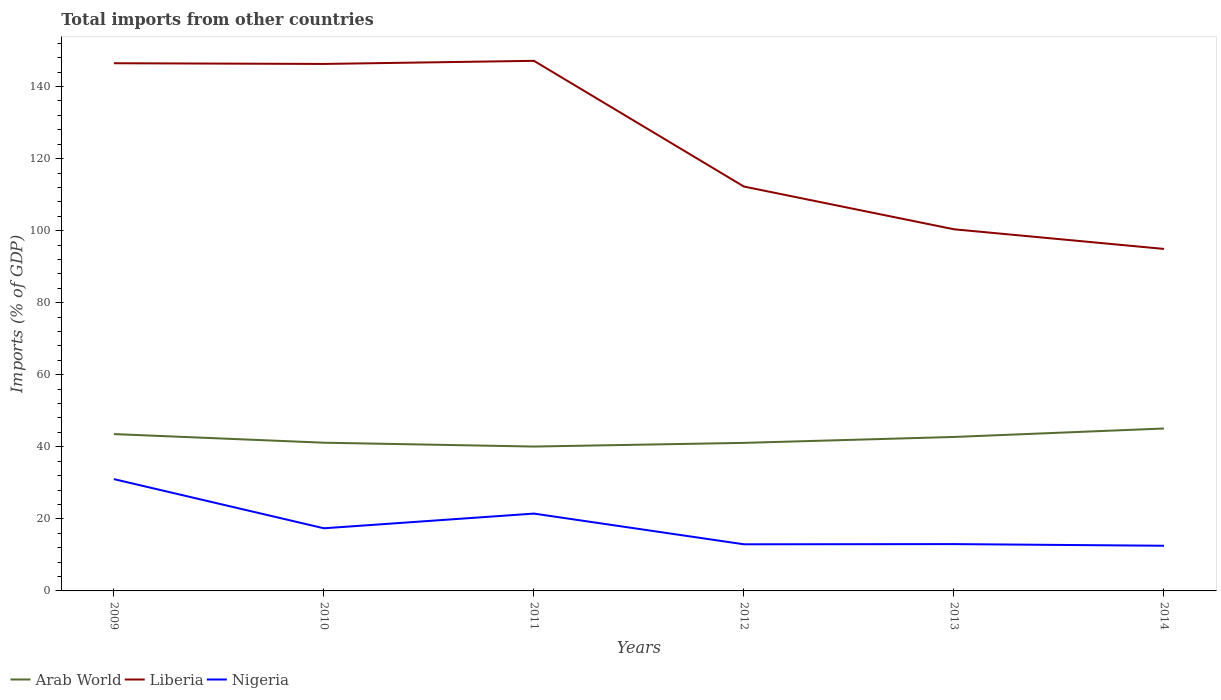Is the number of lines equal to the number of legend labels?
Provide a short and direct response. Yes. Across all years, what is the maximum total imports in Liberia?
Your answer should be very brief. 94.93. What is the total total imports in Nigeria in the graph?
Keep it short and to the point. 8.93. What is the difference between the highest and the second highest total imports in Nigeria?
Provide a succinct answer. 18.5. What is the difference between the highest and the lowest total imports in Liberia?
Your answer should be very brief. 3. Is the total imports in Liberia strictly greater than the total imports in Nigeria over the years?
Provide a short and direct response. No. How many years are there in the graph?
Keep it short and to the point. 6. Are the values on the major ticks of Y-axis written in scientific E-notation?
Your answer should be compact. No. Does the graph contain grids?
Your answer should be very brief. No. Where does the legend appear in the graph?
Provide a succinct answer. Bottom left. What is the title of the graph?
Give a very brief answer. Total imports from other countries. What is the label or title of the X-axis?
Offer a very short reply. Years. What is the label or title of the Y-axis?
Offer a very short reply. Imports (% of GDP). What is the Imports (% of GDP) in Arab World in 2009?
Give a very brief answer. 43.54. What is the Imports (% of GDP) in Liberia in 2009?
Keep it short and to the point. 146.47. What is the Imports (% of GDP) in Nigeria in 2009?
Ensure brevity in your answer.  31.03. What is the Imports (% of GDP) of Arab World in 2010?
Your answer should be very brief. 41.14. What is the Imports (% of GDP) in Liberia in 2010?
Give a very brief answer. 146.28. What is the Imports (% of GDP) in Nigeria in 2010?
Your answer should be compact. 17.39. What is the Imports (% of GDP) of Arab World in 2011?
Offer a terse response. 40.07. What is the Imports (% of GDP) of Liberia in 2011?
Your answer should be compact. 147.15. What is the Imports (% of GDP) of Nigeria in 2011?
Make the answer very short. 21.46. What is the Imports (% of GDP) in Arab World in 2012?
Keep it short and to the point. 41.1. What is the Imports (% of GDP) in Liberia in 2012?
Make the answer very short. 112.24. What is the Imports (% of GDP) of Nigeria in 2012?
Your response must be concise. 12.94. What is the Imports (% of GDP) in Arab World in 2013?
Your answer should be very brief. 42.74. What is the Imports (% of GDP) of Liberia in 2013?
Keep it short and to the point. 100.39. What is the Imports (% of GDP) in Nigeria in 2013?
Your response must be concise. 13. What is the Imports (% of GDP) of Arab World in 2014?
Give a very brief answer. 45.08. What is the Imports (% of GDP) of Liberia in 2014?
Give a very brief answer. 94.93. What is the Imports (% of GDP) of Nigeria in 2014?
Your response must be concise. 12.54. Across all years, what is the maximum Imports (% of GDP) of Arab World?
Offer a terse response. 45.08. Across all years, what is the maximum Imports (% of GDP) in Liberia?
Keep it short and to the point. 147.15. Across all years, what is the maximum Imports (% of GDP) of Nigeria?
Your answer should be very brief. 31.03. Across all years, what is the minimum Imports (% of GDP) in Arab World?
Your response must be concise. 40.07. Across all years, what is the minimum Imports (% of GDP) of Liberia?
Keep it short and to the point. 94.93. Across all years, what is the minimum Imports (% of GDP) in Nigeria?
Ensure brevity in your answer.  12.54. What is the total Imports (% of GDP) of Arab World in the graph?
Make the answer very short. 253.67. What is the total Imports (% of GDP) in Liberia in the graph?
Keep it short and to the point. 747.47. What is the total Imports (% of GDP) in Nigeria in the graph?
Provide a short and direct response. 108.36. What is the difference between the Imports (% of GDP) in Arab World in 2009 and that in 2010?
Your response must be concise. 2.39. What is the difference between the Imports (% of GDP) in Liberia in 2009 and that in 2010?
Make the answer very short. 0.19. What is the difference between the Imports (% of GDP) in Nigeria in 2009 and that in 2010?
Offer a very short reply. 13.65. What is the difference between the Imports (% of GDP) of Arab World in 2009 and that in 2011?
Make the answer very short. 3.46. What is the difference between the Imports (% of GDP) in Liberia in 2009 and that in 2011?
Ensure brevity in your answer.  -0.67. What is the difference between the Imports (% of GDP) of Nigeria in 2009 and that in 2011?
Offer a very short reply. 9.57. What is the difference between the Imports (% of GDP) in Arab World in 2009 and that in 2012?
Keep it short and to the point. 2.44. What is the difference between the Imports (% of GDP) of Liberia in 2009 and that in 2012?
Offer a terse response. 34.23. What is the difference between the Imports (% of GDP) in Nigeria in 2009 and that in 2012?
Provide a succinct answer. 18.09. What is the difference between the Imports (% of GDP) in Arab World in 2009 and that in 2013?
Ensure brevity in your answer.  0.8. What is the difference between the Imports (% of GDP) in Liberia in 2009 and that in 2013?
Give a very brief answer. 46.09. What is the difference between the Imports (% of GDP) of Nigeria in 2009 and that in 2013?
Your response must be concise. 18.04. What is the difference between the Imports (% of GDP) in Arab World in 2009 and that in 2014?
Keep it short and to the point. -1.55. What is the difference between the Imports (% of GDP) of Liberia in 2009 and that in 2014?
Offer a very short reply. 51.54. What is the difference between the Imports (% of GDP) in Nigeria in 2009 and that in 2014?
Keep it short and to the point. 18.5. What is the difference between the Imports (% of GDP) in Arab World in 2010 and that in 2011?
Your answer should be very brief. 1.07. What is the difference between the Imports (% of GDP) of Liberia in 2010 and that in 2011?
Your answer should be very brief. -0.86. What is the difference between the Imports (% of GDP) in Nigeria in 2010 and that in 2011?
Offer a very short reply. -4.08. What is the difference between the Imports (% of GDP) of Arab World in 2010 and that in 2012?
Provide a short and direct response. 0.05. What is the difference between the Imports (% of GDP) in Liberia in 2010 and that in 2012?
Your response must be concise. 34.04. What is the difference between the Imports (% of GDP) in Nigeria in 2010 and that in 2012?
Your answer should be very brief. 4.45. What is the difference between the Imports (% of GDP) of Arab World in 2010 and that in 2013?
Give a very brief answer. -1.59. What is the difference between the Imports (% of GDP) in Liberia in 2010 and that in 2013?
Ensure brevity in your answer.  45.9. What is the difference between the Imports (% of GDP) in Nigeria in 2010 and that in 2013?
Provide a short and direct response. 4.39. What is the difference between the Imports (% of GDP) in Arab World in 2010 and that in 2014?
Provide a short and direct response. -3.94. What is the difference between the Imports (% of GDP) of Liberia in 2010 and that in 2014?
Your response must be concise. 51.35. What is the difference between the Imports (% of GDP) in Nigeria in 2010 and that in 2014?
Provide a succinct answer. 4.85. What is the difference between the Imports (% of GDP) in Arab World in 2011 and that in 2012?
Your response must be concise. -1.02. What is the difference between the Imports (% of GDP) of Liberia in 2011 and that in 2012?
Your answer should be compact. 34.9. What is the difference between the Imports (% of GDP) of Nigeria in 2011 and that in 2012?
Your answer should be very brief. 8.52. What is the difference between the Imports (% of GDP) in Arab World in 2011 and that in 2013?
Offer a very short reply. -2.66. What is the difference between the Imports (% of GDP) in Liberia in 2011 and that in 2013?
Your response must be concise. 46.76. What is the difference between the Imports (% of GDP) of Nigeria in 2011 and that in 2013?
Ensure brevity in your answer.  8.47. What is the difference between the Imports (% of GDP) of Arab World in 2011 and that in 2014?
Keep it short and to the point. -5.01. What is the difference between the Imports (% of GDP) of Liberia in 2011 and that in 2014?
Ensure brevity in your answer.  52.21. What is the difference between the Imports (% of GDP) in Nigeria in 2011 and that in 2014?
Your answer should be very brief. 8.93. What is the difference between the Imports (% of GDP) in Arab World in 2012 and that in 2013?
Offer a very short reply. -1.64. What is the difference between the Imports (% of GDP) in Liberia in 2012 and that in 2013?
Ensure brevity in your answer.  11.86. What is the difference between the Imports (% of GDP) of Nigeria in 2012 and that in 2013?
Ensure brevity in your answer.  -0.06. What is the difference between the Imports (% of GDP) of Arab World in 2012 and that in 2014?
Offer a very short reply. -3.99. What is the difference between the Imports (% of GDP) in Liberia in 2012 and that in 2014?
Your answer should be very brief. 17.31. What is the difference between the Imports (% of GDP) in Nigeria in 2012 and that in 2014?
Keep it short and to the point. 0.4. What is the difference between the Imports (% of GDP) in Arab World in 2013 and that in 2014?
Your response must be concise. -2.35. What is the difference between the Imports (% of GDP) of Liberia in 2013 and that in 2014?
Give a very brief answer. 5.45. What is the difference between the Imports (% of GDP) of Nigeria in 2013 and that in 2014?
Provide a short and direct response. 0.46. What is the difference between the Imports (% of GDP) in Arab World in 2009 and the Imports (% of GDP) in Liberia in 2010?
Give a very brief answer. -102.75. What is the difference between the Imports (% of GDP) of Arab World in 2009 and the Imports (% of GDP) of Nigeria in 2010?
Your answer should be very brief. 26.15. What is the difference between the Imports (% of GDP) in Liberia in 2009 and the Imports (% of GDP) in Nigeria in 2010?
Your answer should be compact. 129.09. What is the difference between the Imports (% of GDP) of Arab World in 2009 and the Imports (% of GDP) of Liberia in 2011?
Your response must be concise. -103.61. What is the difference between the Imports (% of GDP) in Arab World in 2009 and the Imports (% of GDP) in Nigeria in 2011?
Offer a terse response. 22.07. What is the difference between the Imports (% of GDP) in Liberia in 2009 and the Imports (% of GDP) in Nigeria in 2011?
Ensure brevity in your answer.  125.01. What is the difference between the Imports (% of GDP) of Arab World in 2009 and the Imports (% of GDP) of Liberia in 2012?
Your answer should be very brief. -68.71. What is the difference between the Imports (% of GDP) of Arab World in 2009 and the Imports (% of GDP) of Nigeria in 2012?
Give a very brief answer. 30.59. What is the difference between the Imports (% of GDP) of Liberia in 2009 and the Imports (% of GDP) of Nigeria in 2012?
Keep it short and to the point. 133.53. What is the difference between the Imports (% of GDP) of Arab World in 2009 and the Imports (% of GDP) of Liberia in 2013?
Provide a succinct answer. -56.85. What is the difference between the Imports (% of GDP) in Arab World in 2009 and the Imports (% of GDP) in Nigeria in 2013?
Your answer should be compact. 30.54. What is the difference between the Imports (% of GDP) of Liberia in 2009 and the Imports (% of GDP) of Nigeria in 2013?
Keep it short and to the point. 133.48. What is the difference between the Imports (% of GDP) of Arab World in 2009 and the Imports (% of GDP) of Liberia in 2014?
Give a very brief answer. -51.4. What is the difference between the Imports (% of GDP) of Arab World in 2009 and the Imports (% of GDP) of Nigeria in 2014?
Offer a terse response. 31. What is the difference between the Imports (% of GDP) in Liberia in 2009 and the Imports (% of GDP) in Nigeria in 2014?
Keep it short and to the point. 133.94. What is the difference between the Imports (% of GDP) in Arab World in 2010 and the Imports (% of GDP) in Liberia in 2011?
Give a very brief answer. -106. What is the difference between the Imports (% of GDP) of Arab World in 2010 and the Imports (% of GDP) of Nigeria in 2011?
Your answer should be compact. 19.68. What is the difference between the Imports (% of GDP) of Liberia in 2010 and the Imports (% of GDP) of Nigeria in 2011?
Offer a terse response. 124.82. What is the difference between the Imports (% of GDP) of Arab World in 2010 and the Imports (% of GDP) of Liberia in 2012?
Your response must be concise. -71.1. What is the difference between the Imports (% of GDP) in Arab World in 2010 and the Imports (% of GDP) in Nigeria in 2012?
Offer a very short reply. 28.2. What is the difference between the Imports (% of GDP) of Liberia in 2010 and the Imports (% of GDP) of Nigeria in 2012?
Your answer should be compact. 133.34. What is the difference between the Imports (% of GDP) of Arab World in 2010 and the Imports (% of GDP) of Liberia in 2013?
Offer a very short reply. -59.24. What is the difference between the Imports (% of GDP) in Arab World in 2010 and the Imports (% of GDP) in Nigeria in 2013?
Your answer should be compact. 28.14. What is the difference between the Imports (% of GDP) of Liberia in 2010 and the Imports (% of GDP) of Nigeria in 2013?
Give a very brief answer. 133.28. What is the difference between the Imports (% of GDP) in Arab World in 2010 and the Imports (% of GDP) in Liberia in 2014?
Offer a terse response. -53.79. What is the difference between the Imports (% of GDP) of Arab World in 2010 and the Imports (% of GDP) of Nigeria in 2014?
Offer a very short reply. 28.61. What is the difference between the Imports (% of GDP) of Liberia in 2010 and the Imports (% of GDP) of Nigeria in 2014?
Give a very brief answer. 133.75. What is the difference between the Imports (% of GDP) in Arab World in 2011 and the Imports (% of GDP) in Liberia in 2012?
Provide a short and direct response. -72.17. What is the difference between the Imports (% of GDP) in Arab World in 2011 and the Imports (% of GDP) in Nigeria in 2012?
Your response must be concise. 27.13. What is the difference between the Imports (% of GDP) of Liberia in 2011 and the Imports (% of GDP) of Nigeria in 2012?
Provide a succinct answer. 134.21. What is the difference between the Imports (% of GDP) of Arab World in 2011 and the Imports (% of GDP) of Liberia in 2013?
Your answer should be compact. -60.31. What is the difference between the Imports (% of GDP) of Arab World in 2011 and the Imports (% of GDP) of Nigeria in 2013?
Make the answer very short. 27.08. What is the difference between the Imports (% of GDP) in Liberia in 2011 and the Imports (% of GDP) in Nigeria in 2013?
Keep it short and to the point. 134.15. What is the difference between the Imports (% of GDP) in Arab World in 2011 and the Imports (% of GDP) in Liberia in 2014?
Provide a short and direct response. -54.86. What is the difference between the Imports (% of GDP) in Arab World in 2011 and the Imports (% of GDP) in Nigeria in 2014?
Ensure brevity in your answer.  27.54. What is the difference between the Imports (% of GDP) of Liberia in 2011 and the Imports (% of GDP) of Nigeria in 2014?
Your answer should be compact. 134.61. What is the difference between the Imports (% of GDP) in Arab World in 2012 and the Imports (% of GDP) in Liberia in 2013?
Ensure brevity in your answer.  -59.29. What is the difference between the Imports (% of GDP) of Arab World in 2012 and the Imports (% of GDP) of Nigeria in 2013?
Make the answer very short. 28.1. What is the difference between the Imports (% of GDP) in Liberia in 2012 and the Imports (% of GDP) in Nigeria in 2013?
Your response must be concise. 99.25. What is the difference between the Imports (% of GDP) in Arab World in 2012 and the Imports (% of GDP) in Liberia in 2014?
Ensure brevity in your answer.  -53.84. What is the difference between the Imports (% of GDP) in Arab World in 2012 and the Imports (% of GDP) in Nigeria in 2014?
Your answer should be compact. 28.56. What is the difference between the Imports (% of GDP) in Liberia in 2012 and the Imports (% of GDP) in Nigeria in 2014?
Offer a terse response. 99.71. What is the difference between the Imports (% of GDP) of Arab World in 2013 and the Imports (% of GDP) of Liberia in 2014?
Provide a succinct answer. -52.2. What is the difference between the Imports (% of GDP) of Arab World in 2013 and the Imports (% of GDP) of Nigeria in 2014?
Offer a very short reply. 30.2. What is the difference between the Imports (% of GDP) of Liberia in 2013 and the Imports (% of GDP) of Nigeria in 2014?
Make the answer very short. 87.85. What is the average Imports (% of GDP) in Arab World per year?
Your answer should be compact. 42.28. What is the average Imports (% of GDP) of Liberia per year?
Provide a short and direct response. 124.58. What is the average Imports (% of GDP) in Nigeria per year?
Ensure brevity in your answer.  18.06. In the year 2009, what is the difference between the Imports (% of GDP) of Arab World and Imports (% of GDP) of Liberia?
Your answer should be compact. -102.94. In the year 2009, what is the difference between the Imports (% of GDP) in Arab World and Imports (% of GDP) in Nigeria?
Your answer should be very brief. 12.5. In the year 2009, what is the difference between the Imports (% of GDP) in Liberia and Imports (% of GDP) in Nigeria?
Your answer should be compact. 115.44. In the year 2010, what is the difference between the Imports (% of GDP) of Arab World and Imports (% of GDP) of Liberia?
Your answer should be very brief. -105.14. In the year 2010, what is the difference between the Imports (% of GDP) in Arab World and Imports (% of GDP) in Nigeria?
Your response must be concise. 23.76. In the year 2010, what is the difference between the Imports (% of GDP) in Liberia and Imports (% of GDP) in Nigeria?
Your response must be concise. 128.9. In the year 2011, what is the difference between the Imports (% of GDP) of Arab World and Imports (% of GDP) of Liberia?
Your answer should be compact. -107.07. In the year 2011, what is the difference between the Imports (% of GDP) of Arab World and Imports (% of GDP) of Nigeria?
Offer a terse response. 18.61. In the year 2011, what is the difference between the Imports (% of GDP) of Liberia and Imports (% of GDP) of Nigeria?
Your answer should be very brief. 125.68. In the year 2012, what is the difference between the Imports (% of GDP) in Arab World and Imports (% of GDP) in Liberia?
Your answer should be very brief. -71.15. In the year 2012, what is the difference between the Imports (% of GDP) of Arab World and Imports (% of GDP) of Nigeria?
Make the answer very short. 28.16. In the year 2012, what is the difference between the Imports (% of GDP) of Liberia and Imports (% of GDP) of Nigeria?
Provide a short and direct response. 99.3. In the year 2013, what is the difference between the Imports (% of GDP) in Arab World and Imports (% of GDP) in Liberia?
Keep it short and to the point. -57.65. In the year 2013, what is the difference between the Imports (% of GDP) in Arab World and Imports (% of GDP) in Nigeria?
Provide a short and direct response. 29.74. In the year 2013, what is the difference between the Imports (% of GDP) of Liberia and Imports (% of GDP) of Nigeria?
Offer a terse response. 87.39. In the year 2014, what is the difference between the Imports (% of GDP) in Arab World and Imports (% of GDP) in Liberia?
Your answer should be very brief. -49.85. In the year 2014, what is the difference between the Imports (% of GDP) in Arab World and Imports (% of GDP) in Nigeria?
Your answer should be compact. 32.55. In the year 2014, what is the difference between the Imports (% of GDP) in Liberia and Imports (% of GDP) in Nigeria?
Provide a short and direct response. 82.4. What is the ratio of the Imports (% of GDP) of Arab World in 2009 to that in 2010?
Your answer should be compact. 1.06. What is the ratio of the Imports (% of GDP) of Nigeria in 2009 to that in 2010?
Offer a very short reply. 1.78. What is the ratio of the Imports (% of GDP) in Arab World in 2009 to that in 2011?
Your answer should be very brief. 1.09. What is the ratio of the Imports (% of GDP) in Nigeria in 2009 to that in 2011?
Offer a terse response. 1.45. What is the ratio of the Imports (% of GDP) in Arab World in 2009 to that in 2012?
Your response must be concise. 1.06. What is the ratio of the Imports (% of GDP) of Liberia in 2009 to that in 2012?
Your answer should be very brief. 1.3. What is the ratio of the Imports (% of GDP) in Nigeria in 2009 to that in 2012?
Make the answer very short. 2.4. What is the ratio of the Imports (% of GDP) of Arab World in 2009 to that in 2013?
Provide a short and direct response. 1.02. What is the ratio of the Imports (% of GDP) in Liberia in 2009 to that in 2013?
Offer a very short reply. 1.46. What is the ratio of the Imports (% of GDP) in Nigeria in 2009 to that in 2013?
Keep it short and to the point. 2.39. What is the ratio of the Imports (% of GDP) in Arab World in 2009 to that in 2014?
Ensure brevity in your answer.  0.97. What is the ratio of the Imports (% of GDP) in Liberia in 2009 to that in 2014?
Your answer should be compact. 1.54. What is the ratio of the Imports (% of GDP) in Nigeria in 2009 to that in 2014?
Your answer should be compact. 2.48. What is the ratio of the Imports (% of GDP) in Arab World in 2010 to that in 2011?
Offer a terse response. 1.03. What is the ratio of the Imports (% of GDP) of Liberia in 2010 to that in 2011?
Keep it short and to the point. 0.99. What is the ratio of the Imports (% of GDP) in Nigeria in 2010 to that in 2011?
Make the answer very short. 0.81. What is the ratio of the Imports (% of GDP) in Liberia in 2010 to that in 2012?
Offer a very short reply. 1.3. What is the ratio of the Imports (% of GDP) of Nigeria in 2010 to that in 2012?
Your answer should be very brief. 1.34. What is the ratio of the Imports (% of GDP) of Arab World in 2010 to that in 2013?
Your answer should be very brief. 0.96. What is the ratio of the Imports (% of GDP) of Liberia in 2010 to that in 2013?
Provide a succinct answer. 1.46. What is the ratio of the Imports (% of GDP) in Nigeria in 2010 to that in 2013?
Your answer should be very brief. 1.34. What is the ratio of the Imports (% of GDP) of Arab World in 2010 to that in 2014?
Offer a very short reply. 0.91. What is the ratio of the Imports (% of GDP) of Liberia in 2010 to that in 2014?
Ensure brevity in your answer.  1.54. What is the ratio of the Imports (% of GDP) in Nigeria in 2010 to that in 2014?
Offer a very short reply. 1.39. What is the ratio of the Imports (% of GDP) in Arab World in 2011 to that in 2012?
Ensure brevity in your answer.  0.98. What is the ratio of the Imports (% of GDP) in Liberia in 2011 to that in 2012?
Give a very brief answer. 1.31. What is the ratio of the Imports (% of GDP) of Nigeria in 2011 to that in 2012?
Provide a short and direct response. 1.66. What is the ratio of the Imports (% of GDP) in Arab World in 2011 to that in 2013?
Keep it short and to the point. 0.94. What is the ratio of the Imports (% of GDP) in Liberia in 2011 to that in 2013?
Make the answer very short. 1.47. What is the ratio of the Imports (% of GDP) in Nigeria in 2011 to that in 2013?
Your answer should be compact. 1.65. What is the ratio of the Imports (% of GDP) in Arab World in 2011 to that in 2014?
Offer a very short reply. 0.89. What is the ratio of the Imports (% of GDP) in Liberia in 2011 to that in 2014?
Provide a succinct answer. 1.55. What is the ratio of the Imports (% of GDP) of Nigeria in 2011 to that in 2014?
Offer a terse response. 1.71. What is the ratio of the Imports (% of GDP) in Arab World in 2012 to that in 2013?
Ensure brevity in your answer.  0.96. What is the ratio of the Imports (% of GDP) in Liberia in 2012 to that in 2013?
Ensure brevity in your answer.  1.12. What is the ratio of the Imports (% of GDP) in Arab World in 2012 to that in 2014?
Offer a terse response. 0.91. What is the ratio of the Imports (% of GDP) in Liberia in 2012 to that in 2014?
Provide a succinct answer. 1.18. What is the ratio of the Imports (% of GDP) of Nigeria in 2012 to that in 2014?
Offer a terse response. 1.03. What is the ratio of the Imports (% of GDP) of Arab World in 2013 to that in 2014?
Make the answer very short. 0.95. What is the ratio of the Imports (% of GDP) in Liberia in 2013 to that in 2014?
Keep it short and to the point. 1.06. What is the ratio of the Imports (% of GDP) in Nigeria in 2013 to that in 2014?
Provide a short and direct response. 1.04. What is the difference between the highest and the second highest Imports (% of GDP) in Arab World?
Your response must be concise. 1.55. What is the difference between the highest and the second highest Imports (% of GDP) in Liberia?
Your response must be concise. 0.67. What is the difference between the highest and the second highest Imports (% of GDP) in Nigeria?
Give a very brief answer. 9.57. What is the difference between the highest and the lowest Imports (% of GDP) in Arab World?
Provide a short and direct response. 5.01. What is the difference between the highest and the lowest Imports (% of GDP) of Liberia?
Make the answer very short. 52.21. What is the difference between the highest and the lowest Imports (% of GDP) of Nigeria?
Give a very brief answer. 18.5. 